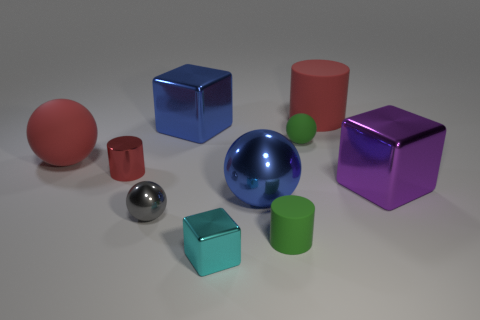Subtract all purple cubes. How many cubes are left? 2 Subtract all cyan cubes. How many red cylinders are left? 2 Subtract all green cylinders. How many cylinders are left? 2 Subtract all cylinders. How many objects are left? 7 Subtract 0 green blocks. How many objects are left? 10 Subtract 3 blocks. How many blocks are left? 0 Subtract all red blocks. Subtract all yellow balls. How many blocks are left? 3 Subtract all small spheres. Subtract all big cylinders. How many objects are left? 7 Add 4 tiny shiny things. How many tiny shiny things are left? 7 Add 1 small cyan metal cubes. How many small cyan metal cubes exist? 2 